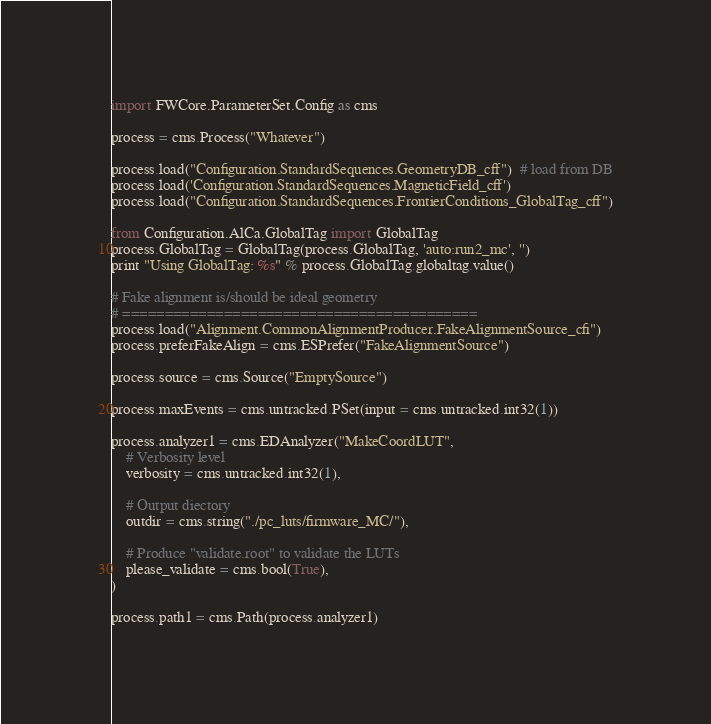Convert code to text. <code><loc_0><loc_0><loc_500><loc_500><_Python_>import FWCore.ParameterSet.Config as cms

process = cms.Process("Whatever")

process.load("Configuration.StandardSequences.GeometryDB_cff")  # load from DB
process.load('Configuration.StandardSequences.MagneticField_cff')
process.load("Configuration.StandardSequences.FrontierConditions_GlobalTag_cff")

from Configuration.AlCa.GlobalTag import GlobalTag
process.GlobalTag = GlobalTag(process.GlobalTag, 'auto:run2_mc', '')
print "Using GlobalTag: %s" % process.GlobalTag.globaltag.value()

# Fake alignment is/should be ideal geometry
# ==========================================
process.load("Alignment.CommonAlignmentProducer.FakeAlignmentSource_cfi")
process.preferFakeAlign = cms.ESPrefer("FakeAlignmentSource")

process.source = cms.Source("EmptySource")

process.maxEvents = cms.untracked.PSet(input = cms.untracked.int32(1))

process.analyzer1 = cms.EDAnalyzer("MakeCoordLUT",
    # Verbosity level
    verbosity = cms.untracked.int32(1),

    # Output diectory
    outdir = cms.string("./pc_luts/firmware_MC/"),

    # Produce "validate.root" to validate the LUTs
    please_validate = cms.bool(True),
)

process.path1 = cms.Path(process.analyzer1)
</code> 